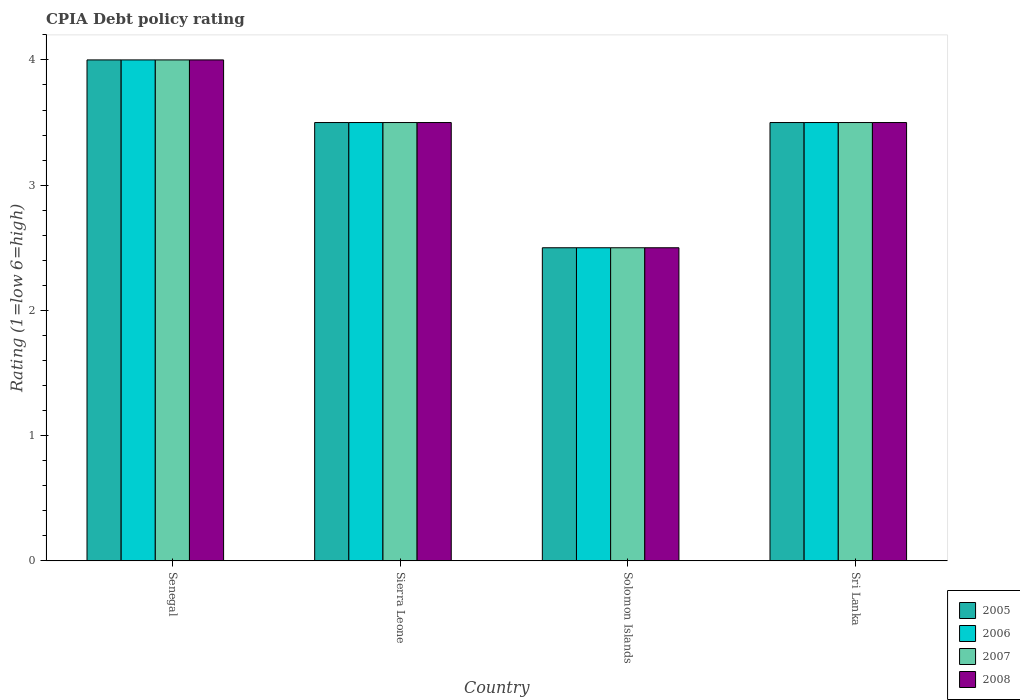How many different coloured bars are there?
Offer a very short reply. 4. How many groups of bars are there?
Offer a very short reply. 4. How many bars are there on the 4th tick from the left?
Your answer should be very brief. 4. What is the label of the 1st group of bars from the left?
Offer a very short reply. Senegal. What is the CPIA rating in 2005 in Sierra Leone?
Offer a terse response. 3.5. Across all countries, what is the maximum CPIA rating in 2006?
Make the answer very short. 4. In which country was the CPIA rating in 2008 maximum?
Provide a succinct answer. Senegal. In which country was the CPIA rating in 2006 minimum?
Provide a short and direct response. Solomon Islands. What is the total CPIA rating in 2005 in the graph?
Provide a succinct answer. 13.5. What is the average CPIA rating in 2007 per country?
Offer a terse response. 3.38. What is the ratio of the CPIA rating in 2005 in Solomon Islands to that in Sri Lanka?
Ensure brevity in your answer.  0.71. Is the CPIA rating in 2008 in Sierra Leone less than that in Sri Lanka?
Keep it short and to the point. No. What is the difference between the highest and the lowest CPIA rating in 2006?
Keep it short and to the point. 1.5. Is it the case that in every country, the sum of the CPIA rating in 2006 and CPIA rating in 2008 is greater than the sum of CPIA rating in 2005 and CPIA rating in 2007?
Offer a very short reply. No. What does the 2nd bar from the right in Solomon Islands represents?
Provide a succinct answer. 2007. Are all the bars in the graph horizontal?
Provide a short and direct response. No. What is the difference between two consecutive major ticks on the Y-axis?
Offer a very short reply. 1. Are the values on the major ticks of Y-axis written in scientific E-notation?
Offer a very short reply. No. Does the graph contain any zero values?
Offer a very short reply. No. Where does the legend appear in the graph?
Keep it short and to the point. Bottom right. What is the title of the graph?
Ensure brevity in your answer.  CPIA Debt policy rating. What is the label or title of the Y-axis?
Give a very brief answer. Rating (1=low 6=high). What is the Rating (1=low 6=high) of 2005 in Senegal?
Keep it short and to the point. 4. What is the Rating (1=low 6=high) of 2006 in Sierra Leone?
Offer a terse response. 3.5. What is the Rating (1=low 6=high) of 2006 in Sri Lanka?
Make the answer very short. 3.5. Across all countries, what is the maximum Rating (1=low 6=high) of 2005?
Keep it short and to the point. 4. Across all countries, what is the minimum Rating (1=low 6=high) of 2005?
Your response must be concise. 2.5. Across all countries, what is the minimum Rating (1=low 6=high) in 2006?
Offer a very short reply. 2.5. Across all countries, what is the minimum Rating (1=low 6=high) in 2008?
Provide a short and direct response. 2.5. What is the total Rating (1=low 6=high) in 2005 in the graph?
Your answer should be compact. 13.5. What is the difference between the Rating (1=low 6=high) of 2005 in Senegal and that in Sierra Leone?
Give a very brief answer. 0.5. What is the difference between the Rating (1=low 6=high) in 2007 in Senegal and that in Solomon Islands?
Make the answer very short. 1.5. What is the difference between the Rating (1=low 6=high) in 2005 in Senegal and that in Sri Lanka?
Provide a succinct answer. 0.5. What is the difference between the Rating (1=low 6=high) in 2006 in Senegal and that in Sri Lanka?
Make the answer very short. 0.5. What is the difference between the Rating (1=low 6=high) in 2007 in Senegal and that in Sri Lanka?
Your answer should be compact. 0.5. What is the difference between the Rating (1=low 6=high) of 2008 in Senegal and that in Sri Lanka?
Your response must be concise. 0.5. What is the difference between the Rating (1=low 6=high) of 2007 in Sierra Leone and that in Sri Lanka?
Provide a succinct answer. 0. What is the difference between the Rating (1=low 6=high) in 2006 in Senegal and the Rating (1=low 6=high) in 2007 in Sierra Leone?
Make the answer very short. 0.5. What is the difference between the Rating (1=low 6=high) in 2005 in Senegal and the Rating (1=low 6=high) in 2006 in Solomon Islands?
Give a very brief answer. 1.5. What is the difference between the Rating (1=low 6=high) in 2005 in Senegal and the Rating (1=low 6=high) in 2007 in Solomon Islands?
Your answer should be compact. 1.5. What is the difference between the Rating (1=low 6=high) in 2006 in Senegal and the Rating (1=low 6=high) in 2007 in Solomon Islands?
Ensure brevity in your answer.  1.5. What is the difference between the Rating (1=low 6=high) of 2007 in Senegal and the Rating (1=low 6=high) of 2008 in Solomon Islands?
Offer a terse response. 1.5. What is the difference between the Rating (1=low 6=high) in 2005 in Senegal and the Rating (1=low 6=high) in 2007 in Sri Lanka?
Ensure brevity in your answer.  0.5. What is the difference between the Rating (1=low 6=high) of 2005 in Senegal and the Rating (1=low 6=high) of 2008 in Sri Lanka?
Keep it short and to the point. 0.5. What is the difference between the Rating (1=low 6=high) of 2005 in Sierra Leone and the Rating (1=low 6=high) of 2006 in Solomon Islands?
Offer a terse response. 1. What is the difference between the Rating (1=low 6=high) of 2005 in Sierra Leone and the Rating (1=low 6=high) of 2008 in Solomon Islands?
Offer a terse response. 1. What is the difference between the Rating (1=low 6=high) of 2006 in Sierra Leone and the Rating (1=low 6=high) of 2007 in Solomon Islands?
Your answer should be very brief. 1. What is the difference between the Rating (1=low 6=high) of 2007 in Sierra Leone and the Rating (1=low 6=high) of 2008 in Solomon Islands?
Your response must be concise. 1. What is the difference between the Rating (1=low 6=high) in 2005 in Sierra Leone and the Rating (1=low 6=high) in 2007 in Sri Lanka?
Your answer should be very brief. 0. What is the difference between the Rating (1=low 6=high) in 2005 in Solomon Islands and the Rating (1=low 6=high) in 2006 in Sri Lanka?
Ensure brevity in your answer.  -1. What is the difference between the Rating (1=low 6=high) of 2005 in Solomon Islands and the Rating (1=low 6=high) of 2008 in Sri Lanka?
Provide a short and direct response. -1. What is the difference between the Rating (1=low 6=high) in 2006 in Solomon Islands and the Rating (1=low 6=high) in 2007 in Sri Lanka?
Offer a very short reply. -1. What is the average Rating (1=low 6=high) of 2005 per country?
Ensure brevity in your answer.  3.38. What is the average Rating (1=low 6=high) of 2006 per country?
Provide a short and direct response. 3.38. What is the average Rating (1=low 6=high) in 2007 per country?
Keep it short and to the point. 3.38. What is the average Rating (1=low 6=high) of 2008 per country?
Give a very brief answer. 3.38. What is the difference between the Rating (1=low 6=high) of 2006 and Rating (1=low 6=high) of 2007 in Senegal?
Keep it short and to the point. 0. What is the difference between the Rating (1=low 6=high) in 2007 and Rating (1=low 6=high) in 2008 in Senegal?
Your response must be concise. 0. What is the difference between the Rating (1=low 6=high) in 2005 and Rating (1=low 6=high) in 2007 in Sierra Leone?
Your answer should be very brief. 0. What is the difference between the Rating (1=low 6=high) in 2006 and Rating (1=low 6=high) in 2007 in Sierra Leone?
Offer a terse response. 0. What is the difference between the Rating (1=low 6=high) in 2005 and Rating (1=low 6=high) in 2008 in Solomon Islands?
Your response must be concise. 0. What is the difference between the Rating (1=low 6=high) in 2006 and Rating (1=low 6=high) in 2007 in Solomon Islands?
Your answer should be compact. 0. What is the difference between the Rating (1=low 6=high) of 2007 and Rating (1=low 6=high) of 2008 in Solomon Islands?
Provide a succinct answer. 0. What is the difference between the Rating (1=low 6=high) in 2005 and Rating (1=low 6=high) in 2006 in Sri Lanka?
Give a very brief answer. 0. What is the difference between the Rating (1=low 6=high) in 2005 and Rating (1=low 6=high) in 2007 in Sri Lanka?
Ensure brevity in your answer.  0. What is the difference between the Rating (1=low 6=high) in 2005 and Rating (1=low 6=high) in 2008 in Sri Lanka?
Offer a terse response. 0. What is the difference between the Rating (1=low 6=high) in 2007 and Rating (1=low 6=high) in 2008 in Sri Lanka?
Make the answer very short. 0. What is the ratio of the Rating (1=low 6=high) of 2005 in Senegal to that in Sierra Leone?
Ensure brevity in your answer.  1.14. What is the ratio of the Rating (1=low 6=high) of 2006 in Senegal to that in Sierra Leone?
Your response must be concise. 1.14. What is the ratio of the Rating (1=low 6=high) in 2008 in Senegal to that in Sierra Leone?
Provide a succinct answer. 1.14. What is the ratio of the Rating (1=low 6=high) in 2007 in Senegal to that in Solomon Islands?
Give a very brief answer. 1.6. What is the ratio of the Rating (1=low 6=high) of 2008 in Senegal to that in Solomon Islands?
Offer a very short reply. 1.6. What is the ratio of the Rating (1=low 6=high) of 2007 in Senegal to that in Sri Lanka?
Provide a succinct answer. 1.14. What is the ratio of the Rating (1=low 6=high) of 2006 in Sierra Leone to that in Sri Lanka?
Your answer should be very brief. 1. What is the ratio of the Rating (1=low 6=high) in 2006 in Solomon Islands to that in Sri Lanka?
Keep it short and to the point. 0.71. What is the difference between the highest and the second highest Rating (1=low 6=high) in 2006?
Your answer should be very brief. 0.5. What is the difference between the highest and the second highest Rating (1=low 6=high) of 2008?
Provide a succinct answer. 0.5. What is the difference between the highest and the lowest Rating (1=low 6=high) of 2008?
Your answer should be very brief. 1.5. 